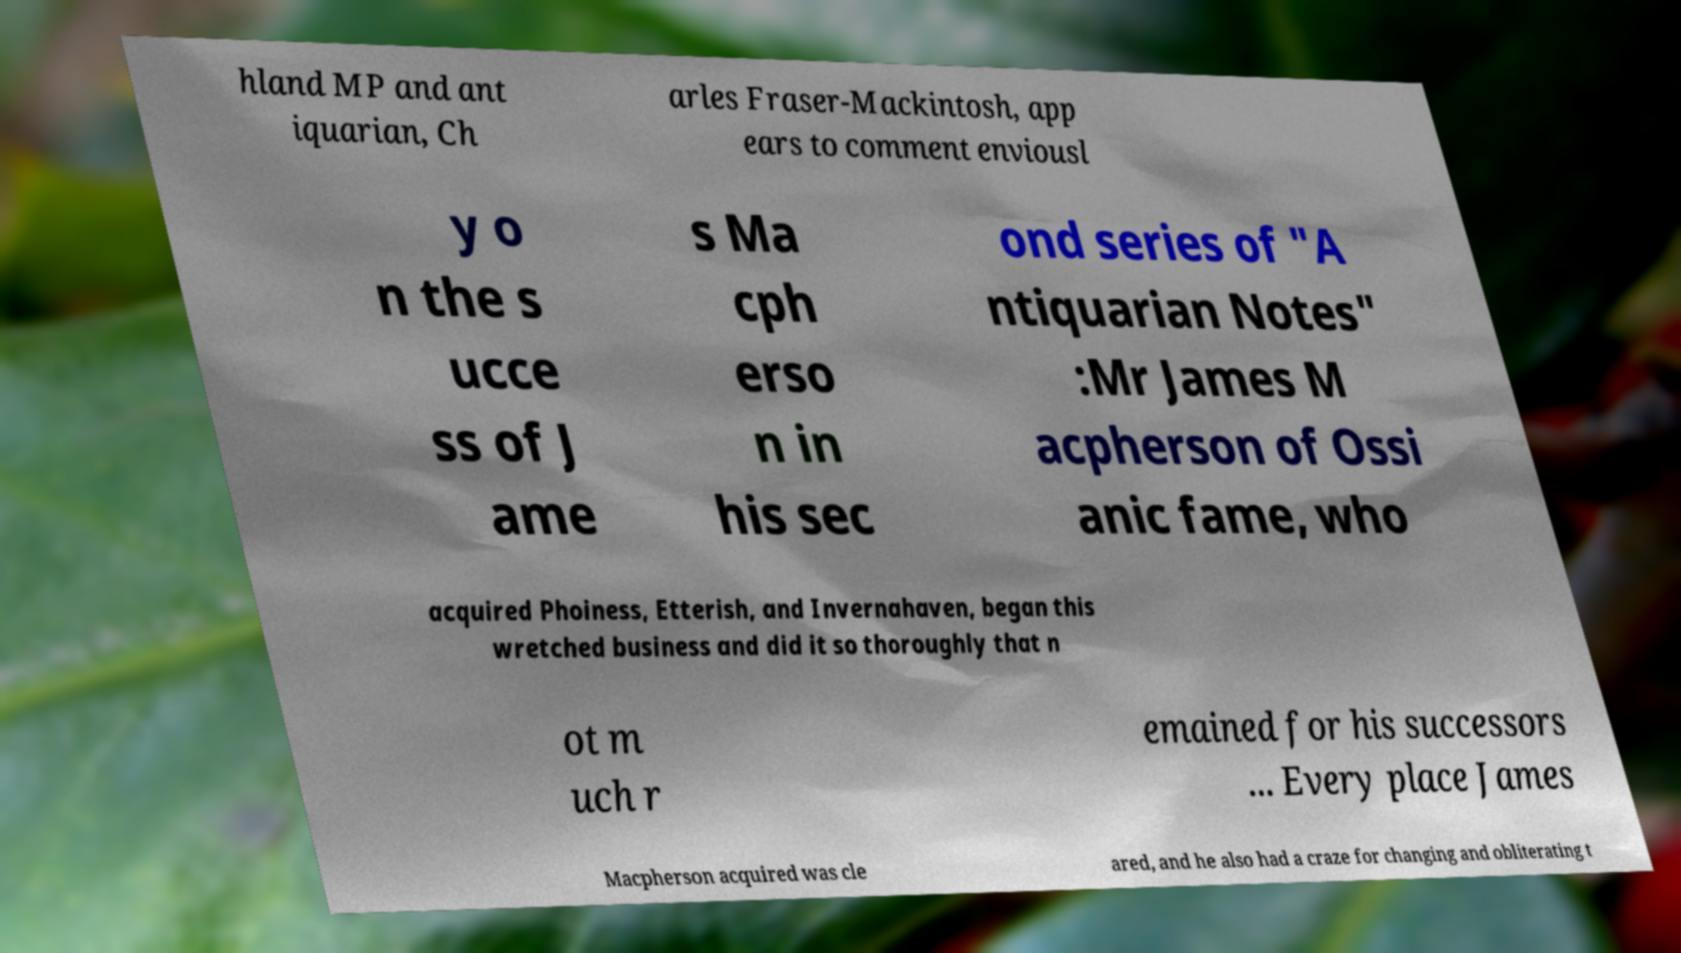There's text embedded in this image that I need extracted. Can you transcribe it verbatim? hland MP and ant iquarian, Ch arles Fraser-Mackintosh, app ears to comment enviousl y o n the s ucce ss of J ame s Ma cph erso n in his sec ond series of "A ntiquarian Notes" :Mr James M acpherson of Ossi anic fame, who acquired Phoiness, Etterish, and Invernahaven, began this wretched business and did it so thoroughly that n ot m uch r emained for his successors ... Every place James Macpherson acquired was cle ared, and he also had a craze for changing and obliterating t 